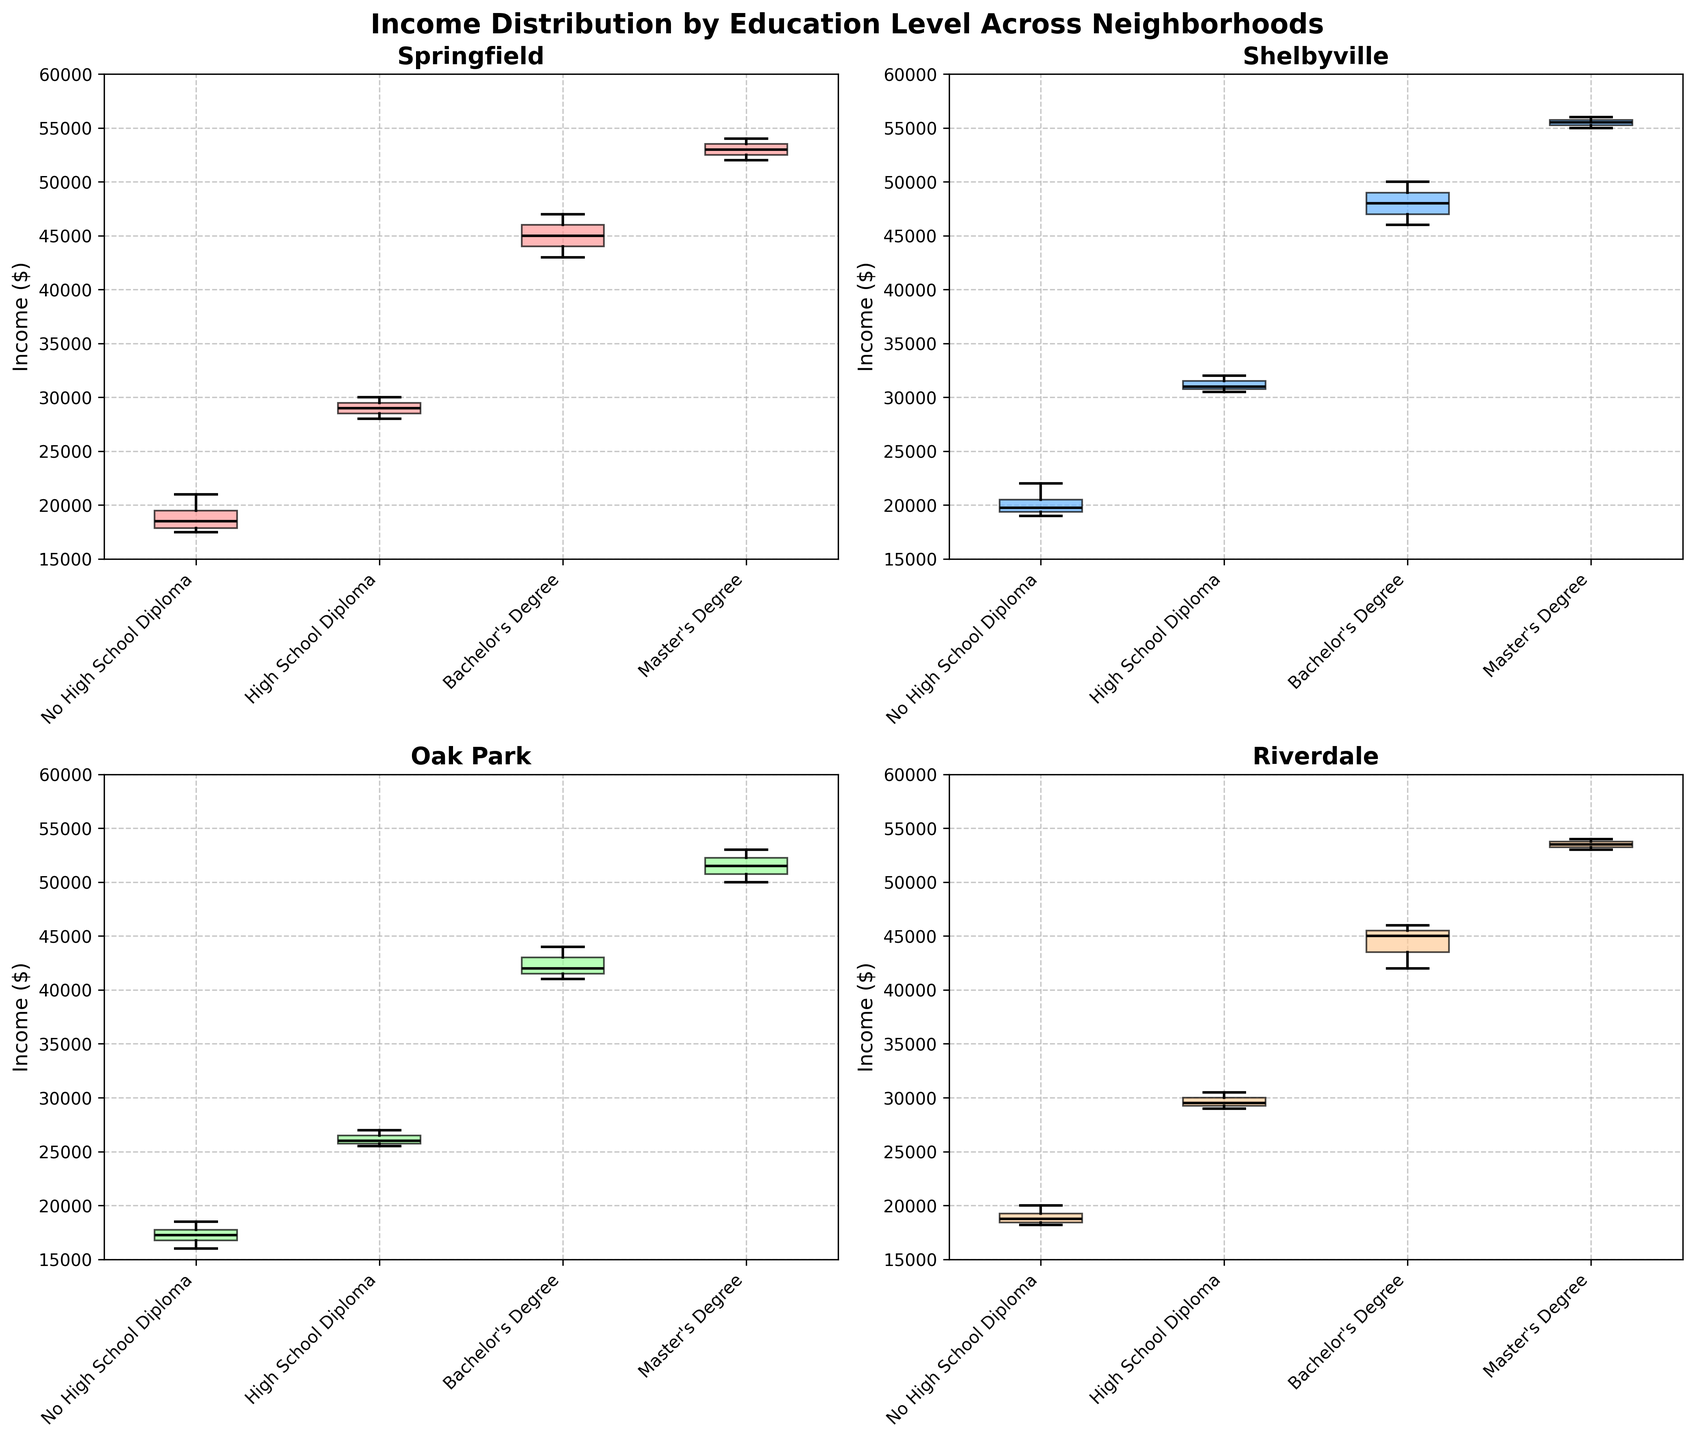what is the title of the figure? The title of the figure is displayed at the top center in bold font.
Answer: Income Distribution by Education Level Across Neighborhoods what is the maximum income value observed in Riverdale for Master’s degree holders? The box plot for Riverdale's Master’s degree holders shows the upper whisker reaching 54,000, making it the maximum value in that category.
Answer: 54000 what is the median income of Bachelor's Degree holders in Shelbyville? The median income is represented by the black horizontal line within the box. For Shelbyville, this line within the box plot for Bachelor's Degree holders aligns with the 48,000 mark.
Answer: 48000 which education level has the widest income range in Oak Park? The education level with the widest income range will have the largest distance between the top whisker and bottom whisker in the box plot. In Oak Park, the Bachelor's Degree plot spans from 41,000 to 44,000, making it the widest range.
Answer: Bachelor's Degree how does the median income of Master's Degree holders compare across different neighborhoods? By looking at the black median lines in the Master's Degree categories of each subplot: Springfield (~53,000), Shelbyville (~55,000), Oak Park (~51,500), and Riverdale (~53,500). Shelbyville's median is the highest, followed by Riverdale and Springfield, and finally Oak Park.
Answer: Highest in Shelbyville which neighborhood has the lowest median income for high school diploma holders? The black median lines inside the boxes for high school diploma holders are lowest in Oak Park, around the 26,000 mark.
Answer: Oak Park is the interquartile range (IQR) for incomes higher in Springfield or Riverdale for no high school diploma holders? The IQR is the range covered by the box itself (from the 25th to the 75th percentile). Riverdale's box appears taller (wider IQR) than Springfield's, suggesting a higher IQR.
Answer: Riverdale which education level shows the least variation (smallest IQR) in Riverdale? The smallest IQR is indicated by the shortest box. For Riverdale, the Bachelor's Degree category has the shortest box, showing the least variation.
Answer: Bachelor's Degree how does the upper whisker of no high school diploma holders in Riverdale compare with that in Springfield? The upper whisker represents the maximum value within 1.5 times the IQR above the upper quartile. For no high school diploma, the upper whisker in Riverdale is at 20,000, while in Springfield, it’s at ~21,000. Hence, Springfield's is higher.
Answer: Higher in Springfield 